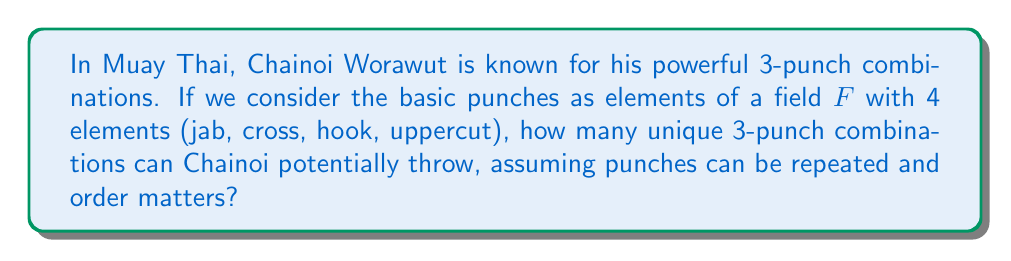Show me your answer to this math problem. Let's approach this step-by-step using field axioms:

1) In field theory, we can consider the set of punches as elements of a field $F$ with 4 elements:
   $F = \{jab, cross, hook, uppercut\}$

2) We need to determine the number of ways to select 3 elements from this field, with repetition allowed and order mattering. This is equivalent to finding $|F \times F \times F|$, where $\times$ denotes the Cartesian product.

3) By the multiplicative property of cardinality for Cartesian products:
   $|F \times F \times F| = |F| \cdot |F| \cdot |F|$

4) We know that $|F| = 4$, so:
   $|F \times F \times F| = 4 \cdot 4 \cdot 4 = 4^3$

5) Using the field axiom of closure under multiplication:
   $4^3 = 4 \cdot 4 \cdot 4 = 64$

Therefore, there are 64 possible unique 3-punch combinations that Chainoi Worawut could potentially throw.
Answer: 64 